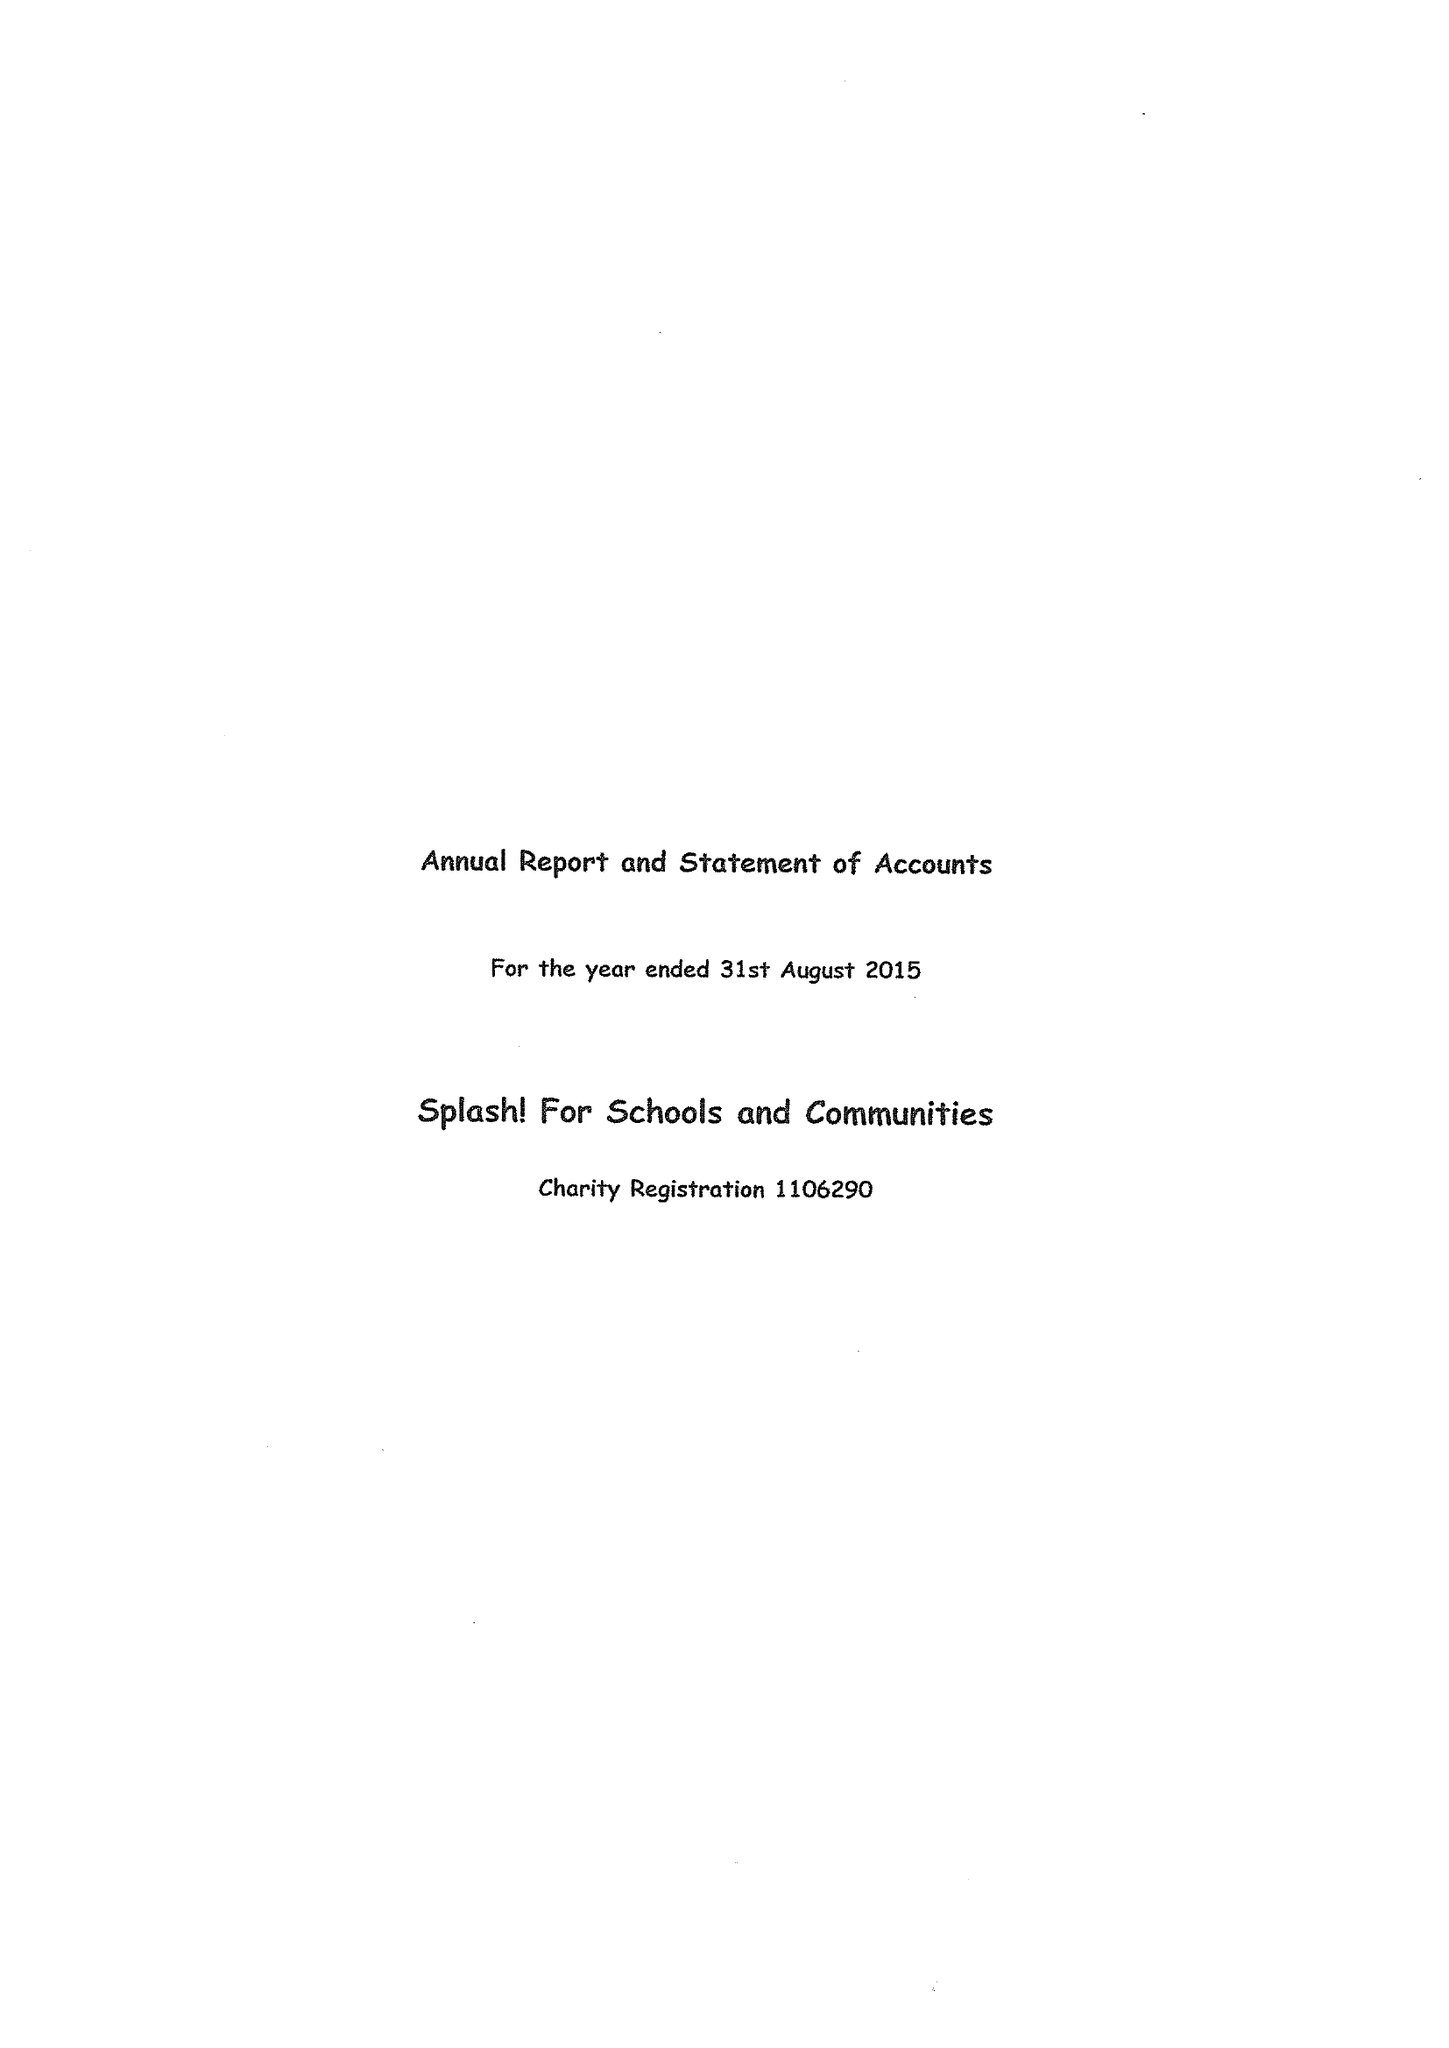What is the value for the address__street_line?
Answer the question using a single word or phrase. CHURCH LANE 